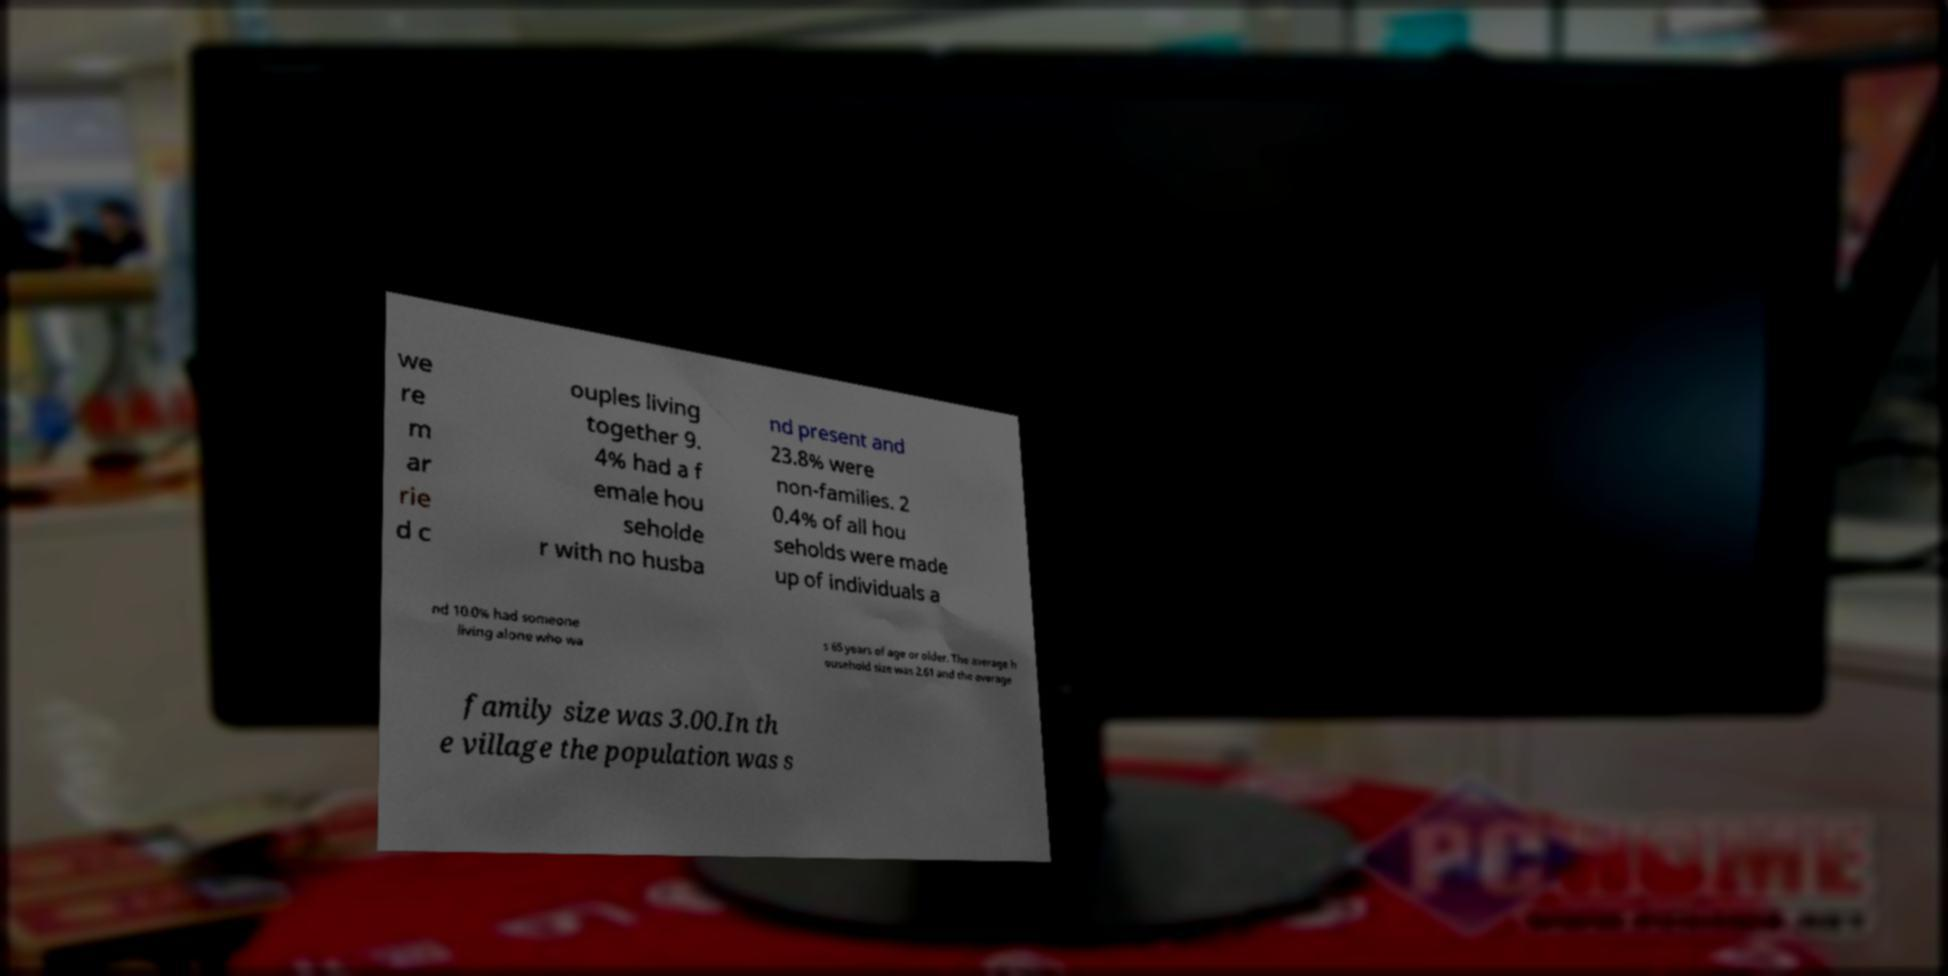Can you read and provide the text displayed in the image?This photo seems to have some interesting text. Can you extract and type it out for me? we re m ar rie d c ouples living together 9. 4% had a f emale hou seholde r with no husba nd present and 23.8% were non-families. 2 0.4% of all hou seholds were made up of individuals a nd 10.0% had someone living alone who wa s 65 years of age or older. The average h ousehold size was 2.61 and the average family size was 3.00.In th e village the population was s 